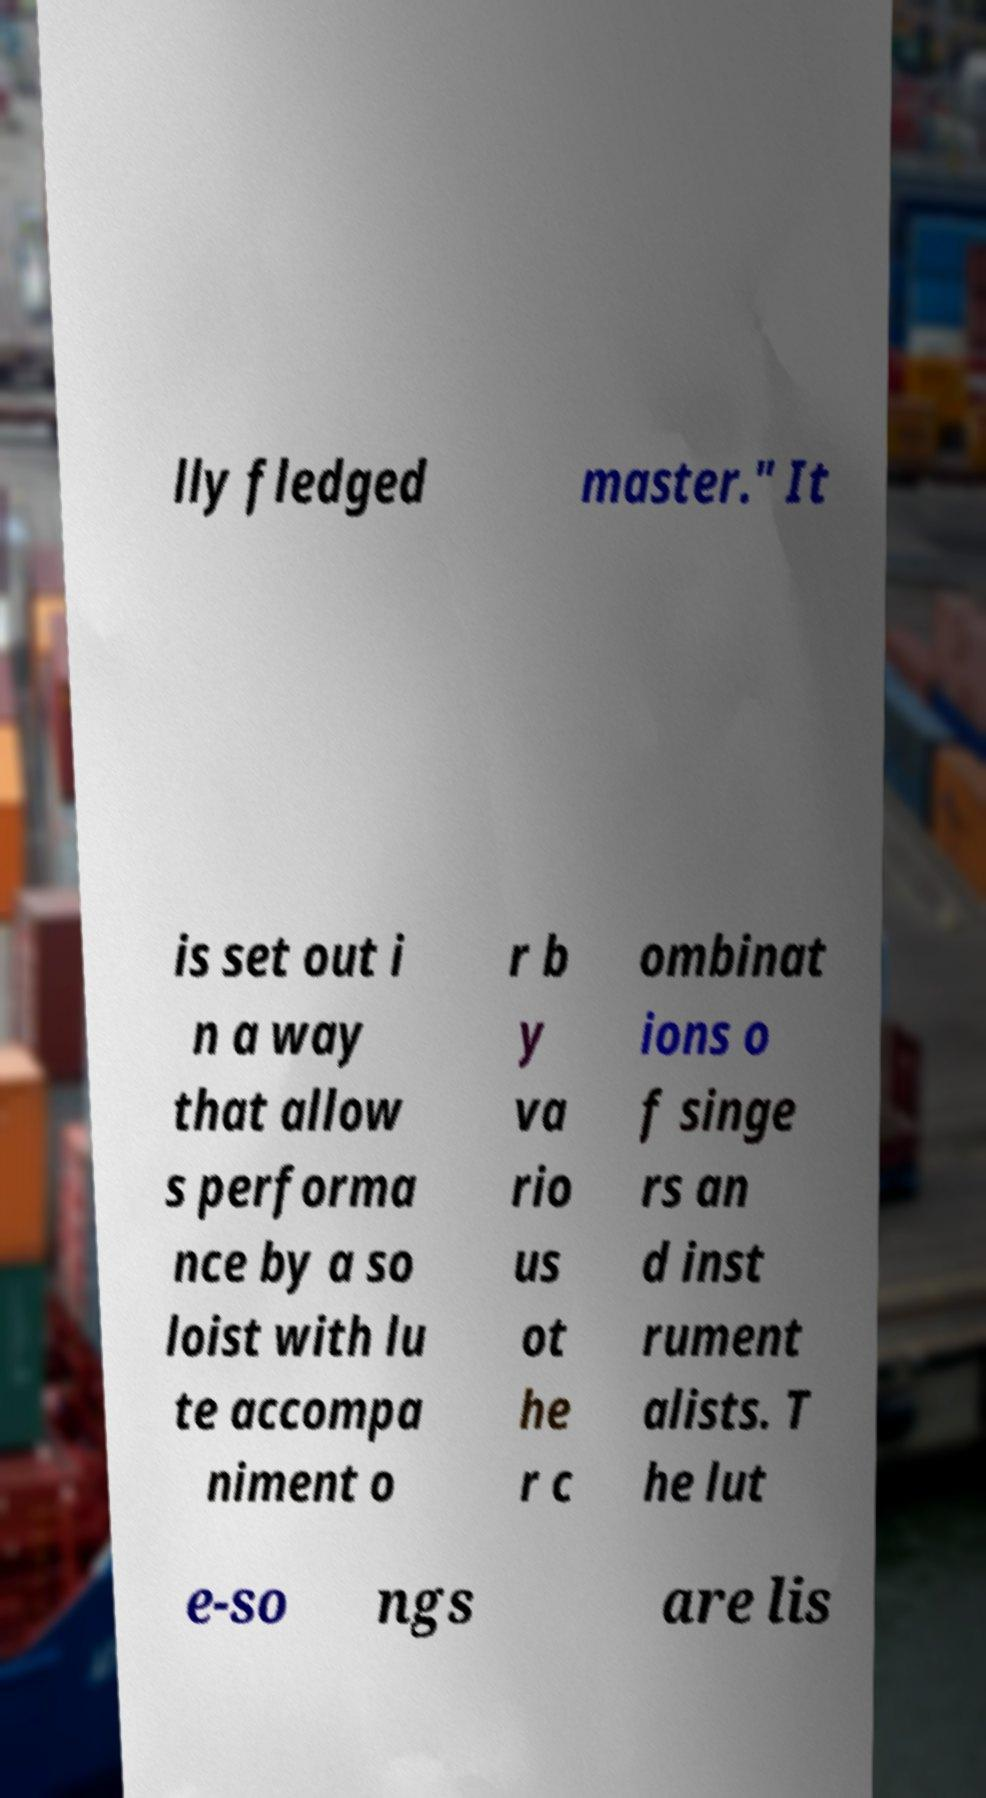For documentation purposes, I need the text within this image transcribed. Could you provide that? lly fledged master." It is set out i n a way that allow s performa nce by a so loist with lu te accompa niment o r b y va rio us ot he r c ombinat ions o f singe rs an d inst rument alists. T he lut e-so ngs are lis 